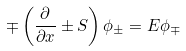Convert formula to latex. <formula><loc_0><loc_0><loc_500><loc_500>\mp \left ( \frac { \partial } { \partial x } \pm S \right ) \phi _ { \pm } = E \phi _ { \mp }</formula> 